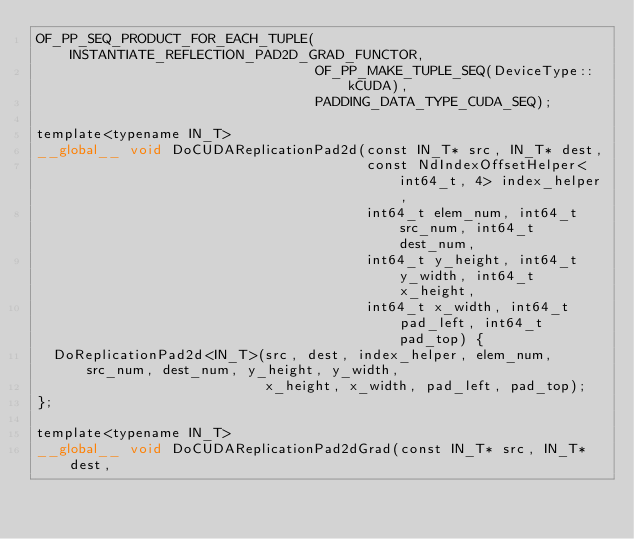<code> <loc_0><loc_0><loc_500><loc_500><_Cuda_>OF_PP_SEQ_PRODUCT_FOR_EACH_TUPLE(INSTANTIATE_REFLECTION_PAD2D_GRAD_FUNCTOR,
                                 OF_PP_MAKE_TUPLE_SEQ(DeviceType::kCUDA),
                                 PADDING_DATA_TYPE_CUDA_SEQ);

template<typename IN_T>
__global__ void DoCUDAReplicationPad2d(const IN_T* src, IN_T* dest,
                                       const NdIndexOffsetHelper<int64_t, 4> index_helper,
                                       int64_t elem_num, int64_t src_num, int64_t dest_num,
                                       int64_t y_height, int64_t y_width, int64_t x_height,
                                       int64_t x_width, int64_t pad_left, int64_t pad_top) {
  DoReplicationPad2d<IN_T>(src, dest, index_helper, elem_num, src_num, dest_num, y_height, y_width,
                           x_height, x_width, pad_left, pad_top);
};

template<typename IN_T>
__global__ void DoCUDAReplicationPad2dGrad(const IN_T* src, IN_T* dest,</code> 